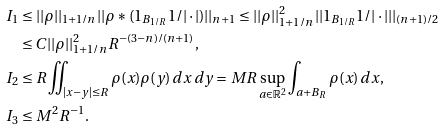Convert formula to latex. <formula><loc_0><loc_0><loc_500><loc_500>I _ { 1 } & \leq | | \rho | | _ { 1 + 1 / n } | | \rho \ast ( 1 _ { B _ { 1 / R } } 1 / | \cdot | ) | | _ { n + 1 } \leq | | \rho | | _ { 1 + 1 / n } ^ { 2 } | | 1 _ { B _ { 1 / R } } 1 / | \cdot | | | _ { ( n + 1 ) / 2 } \\ & \leq C | | \rho | | _ { 1 + 1 / n } ^ { 2 } R ^ { - ( 3 - n ) / ( n + 1 ) } , \\ I _ { 2 } & \leq R \iint _ { | x - y | \leq R } \rho ( x ) \rho ( y ) \, d x \, d y = M R \sup _ { a \in \mathbb { R } ^ { 2 } } \int _ { a + B _ { R } } \rho ( x ) \, d x , \\ I _ { 3 } & \leq M ^ { 2 } R ^ { - 1 } .</formula> 